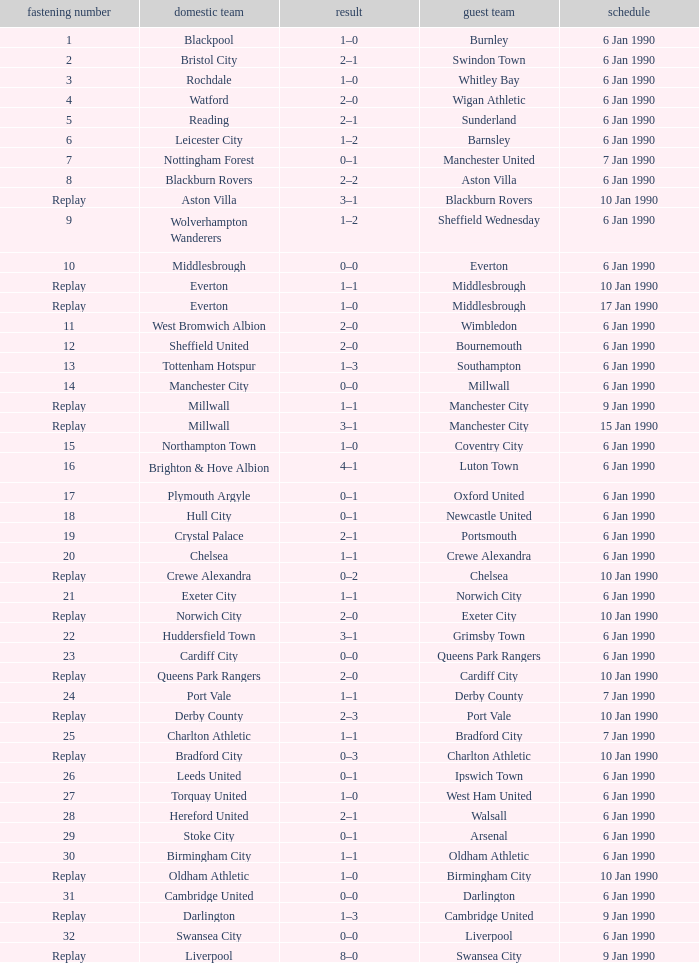What is the score of the game against away team exeter city on 10 jan 1990? 2–0. 